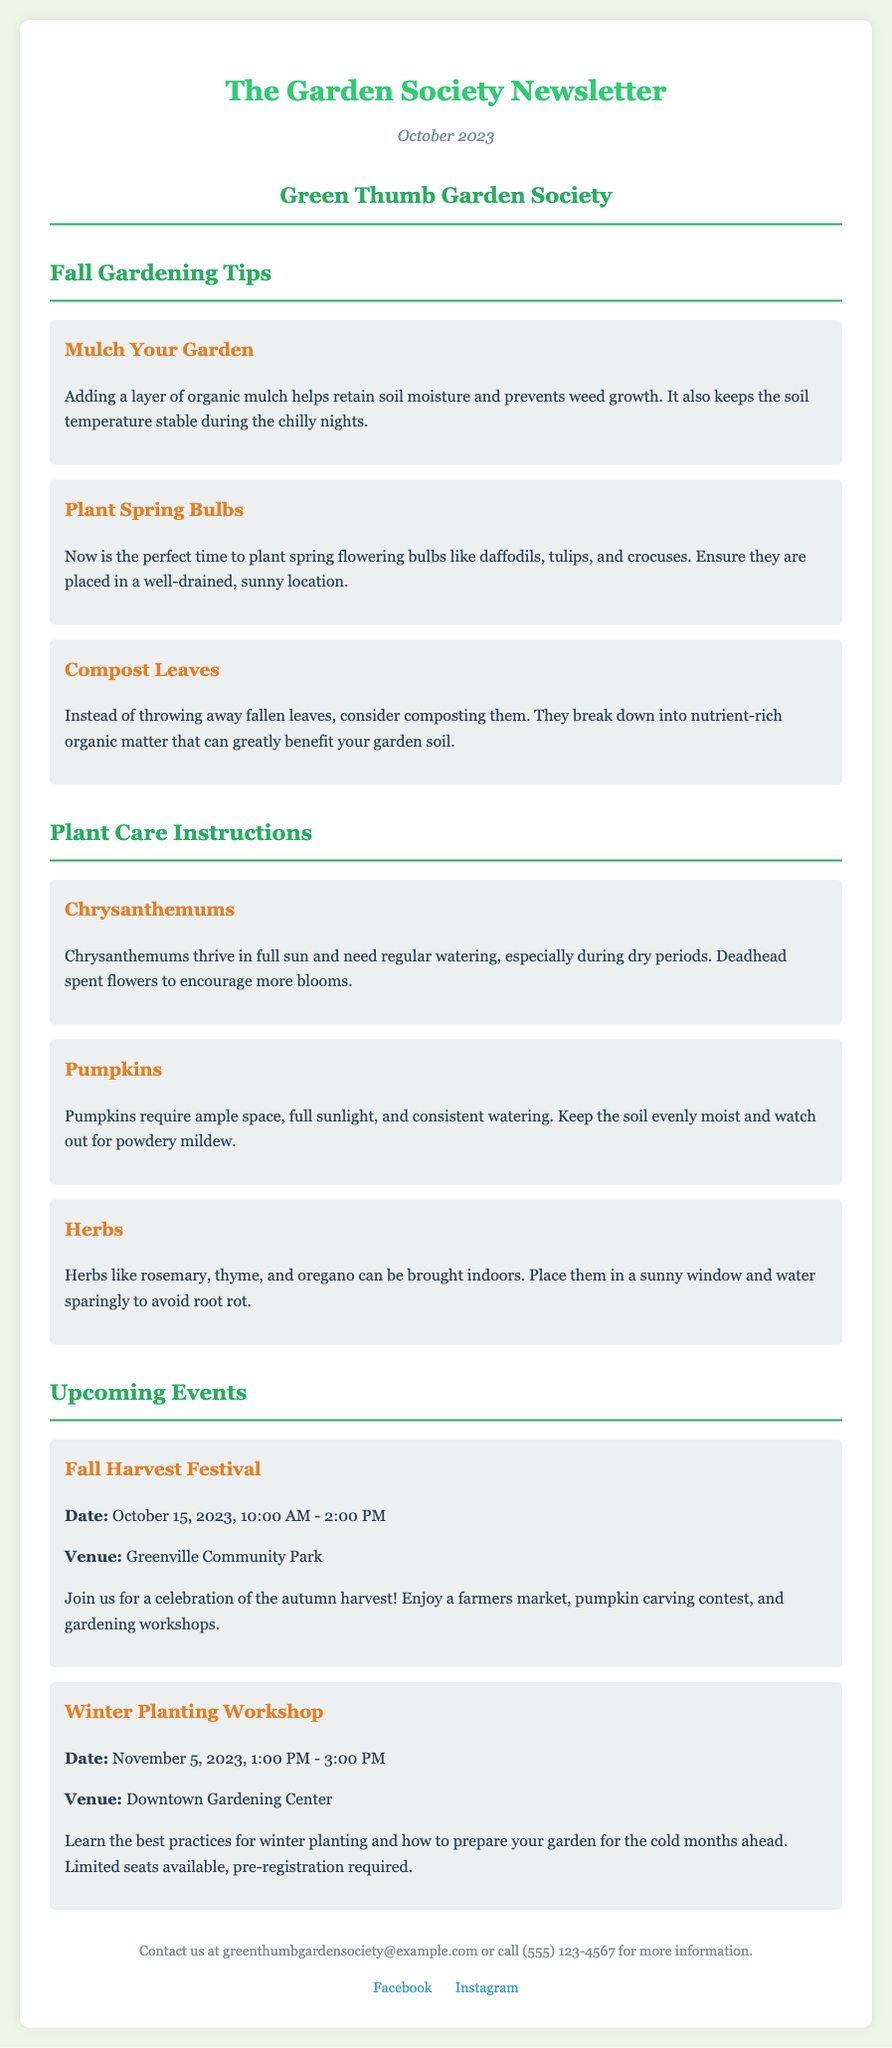What is the title of the newsletter? The title is clearly stated at the top of the document.
Answer: The Garden Society Newsletter What is the issue date of the newsletter? The date is mentioned in the header section of the document.
Answer: October 2023 What is one of the fall gardening tips mentioned? Several tips are listed in the Fall Gardening Tips section; one is selected here.
Answer: Mulch Your Garden What plant is mentioned that requires ample space and full sunlight? The plant care instructions include various plants; this specific plant is referenced.
Answer: Pumpkins When is the Fall Harvest Festival taking place? The event details provide the date and time for the festival.
Answer: October 15, 2023 Where is the Winter Planting Workshop held? The venue for the workshop is specified in the event details.
Answer: Downtown Gardening Center What is the purpose of composting leaves according to the document? This is explained within the context of the gardening tips section.
Answer: Nutrient-rich organic matter How many events are listed in the newsletter? The sections under Upcoming Events indicate the total number of events presented.
Answer: Two What is the contact email provided in the footer? The footer includes specific contact information for inquiries.
Answer: greenthumbgardensociety@example.com 